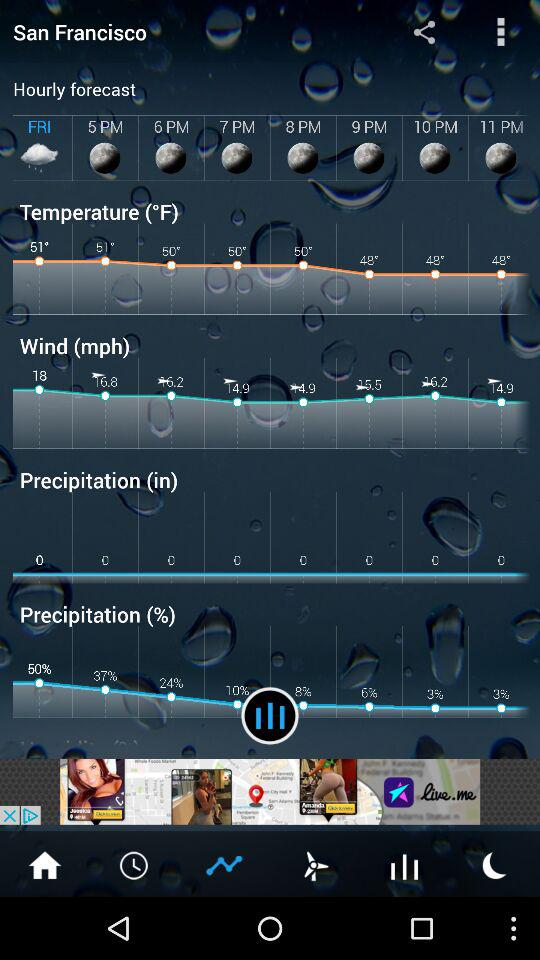What is the measuring unit of temperature? The measuring unit of temperature is °F. 